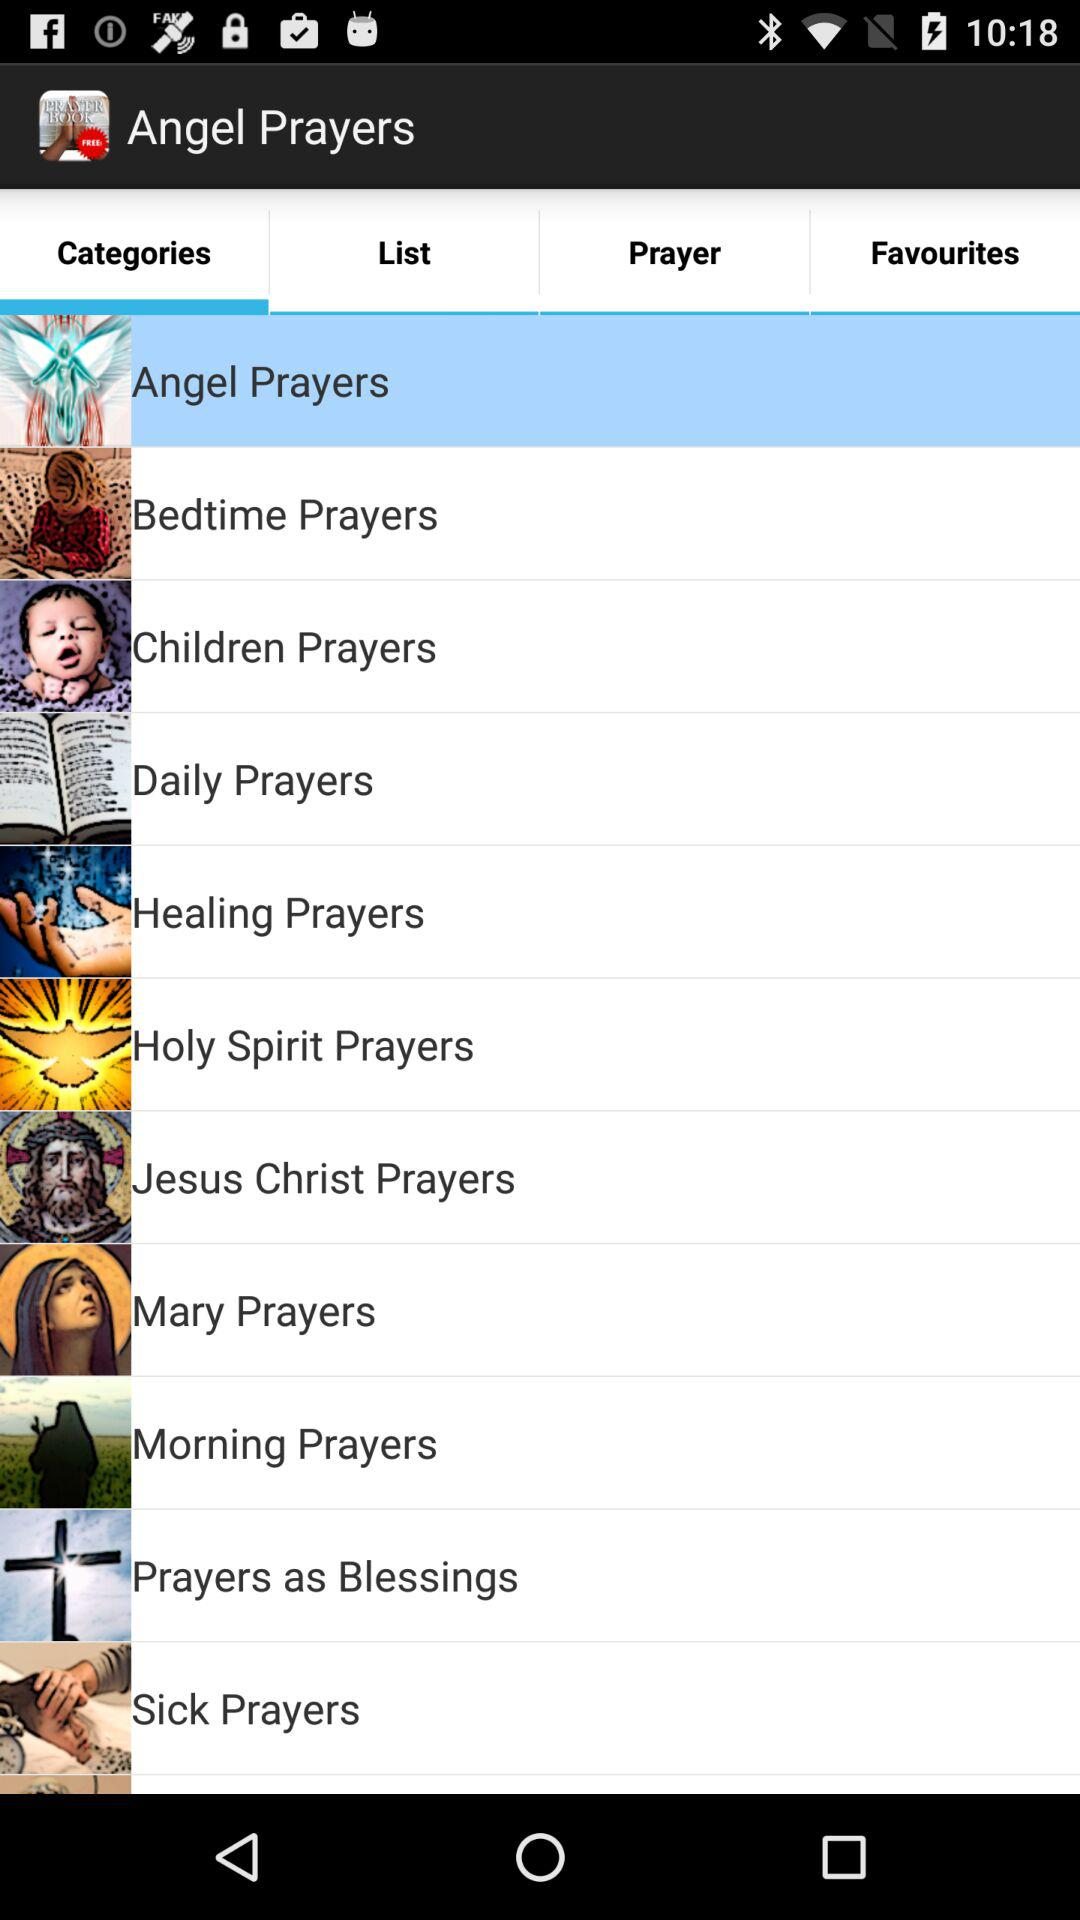Which tab is selected? The selected tab is "Categories". 